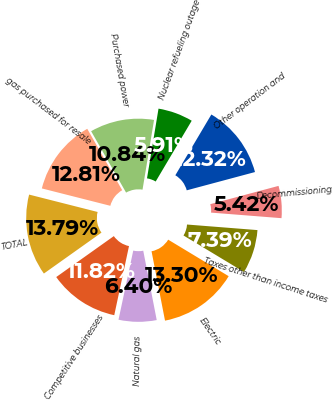Convert chart. <chart><loc_0><loc_0><loc_500><loc_500><pie_chart><fcel>Electric<fcel>Natural gas<fcel>Competitive businesses<fcel>TOTAL<fcel>gas purchased for resale<fcel>Purchased power<fcel>Nuclear refueling outage<fcel>Other operation and<fcel>Decommissioning<fcel>Taxes other than income taxes<nl><fcel>13.3%<fcel>6.4%<fcel>11.82%<fcel>13.79%<fcel>12.81%<fcel>10.84%<fcel>5.91%<fcel>12.32%<fcel>5.42%<fcel>7.39%<nl></chart> 